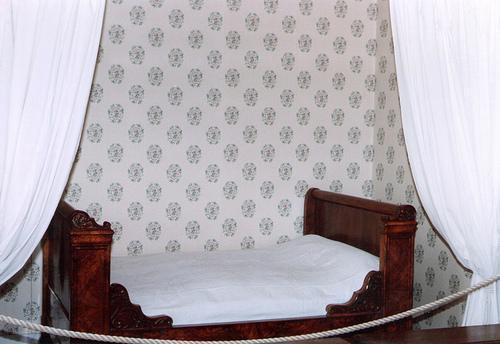How many beds are there?
Give a very brief answer. 1. How many curtains are there?
Give a very brief answer. 2. 